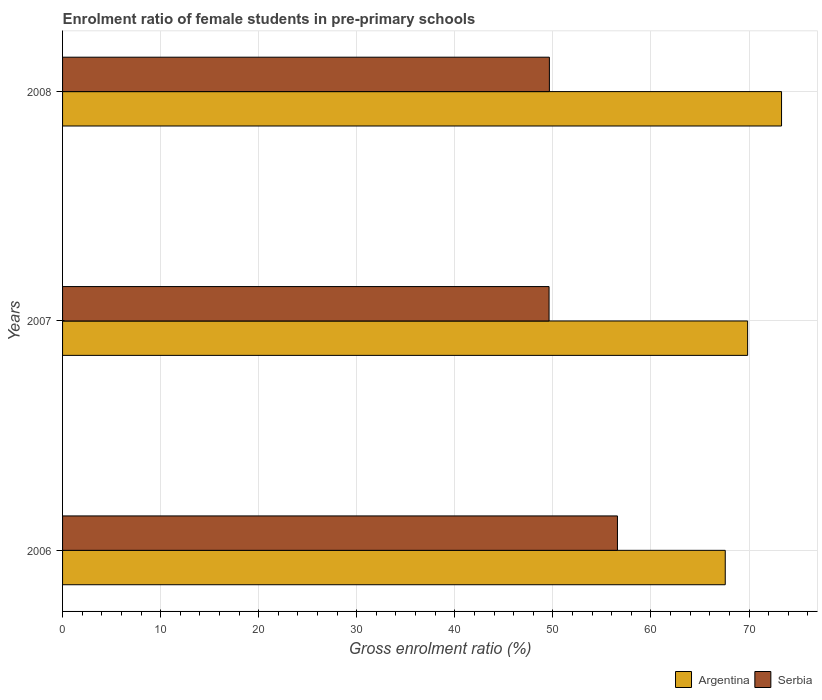How many groups of bars are there?
Your response must be concise. 3. Are the number of bars per tick equal to the number of legend labels?
Provide a short and direct response. Yes. How many bars are there on the 1st tick from the top?
Offer a terse response. 2. In how many cases, is the number of bars for a given year not equal to the number of legend labels?
Your answer should be compact. 0. What is the enrolment ratio of female students in pre-primary schools in Serbia in 2006?
Ensure brevity in your answer.  56.58. Across all years, what is the maximum enrolment ratio of female students in pre-primary schools in Serbia?
Your response must be concise. 56.58. Across all years, what is the minimum enrolment ratio of female students in pre-primary schools in Argentina?
Provide a short and direct response. 67.58. In which year was the enrolment ratio of female students in pre-primary schools in Serbia maximum?
Provide a succinct answer. 2006. What is the total enrolment ratio of female students in pre-primary schools in Argentina in the graph?
Provide a short and direct response. 210.75. What is the difference between the enrolment ratio of female students in pre-primary schools in Serbia in 2007 and that in 2008?
Give a very brief answer. -0.03. What is the difference between the enrolment ratio of female students in pre-primary schools in Argentina in 2008 and the enrolment ratio of female students in pre-primary schools in Serbia in 2007?
Offer a very short reply. 23.71. What is the average enrolment ratio of female students in pre-primary schools in Serbia per year?
Make the answer very short. 51.95. In the year 2006, what is the difference between the enrolment ratio of female students in pre-primary schools in Serbia and enrolment ratio of female students in pre-primary schools in Argentina?
Make the answer very short. -10.99. What is the ratio of the enrolment ratio of female students in pre-primary schools in Argentina in 2006 to that in 2007?
Offer a very short reply. 0.97. Is the difference between the enrolment ratio of female students in pre-primary schools in Serbia in 2006 and 2008 greater than the difference between the enrolment ratio of female students in pre-primary schools in Argentina in 2006 and 2008?
Offer a very short reply. Yes. What is the difference between the highest and the second highest enrolment ratio of female students in pre-primary schools in Argentina?
Offer a terse response. 3.46. What is the difference between the highest and the lowest enrolment ratio of female students in pre-primary schools in Serbia?
Give a very brief answer. 6.97. Is the sum of the enrolment ratio of female students in pre-primary schools in Argentina in 2006 and 2008 greater than the maximum enrolment ratio of female students in pre-primary schools in Serbia across all years?
Your answer should be compact. Yes. How many bars are there?
Provide a short and direct response. 6. Are all the bars in the graph horizontal?
Make the answer very short. Yes. What is the difference between two consecutive major ticks on the X-axis?
Your response must be concise. 10. Where does the legend appear in the graph?
Provide a succinct answer. Bottom right. How many legend labels are there?
Provide a succinct answer. 2. What is the title of the graph?
Your answer should be compact. Enrolment ratio of female students in pre-primary schools. Does "Pacific island small states" appear as one of the legend labels in the graph?
Your answer should be very brief. No. What is the label or title of the X-axis?
Keep it short and to the point. Gross enrolment ratio (%). What is the label or title of the Y-axis?
Offer a very short reply. Years. What is the Gross enrolment ratio (%) of Argentina in 2006?
Provide a succinct answer. 67.58. What is the Gross enrolment ratio (%) in Serbia in 2006?
Provide a succinct answer. 56.58. What is the Gross enrolment ratio (%) of Argentina in 2007?
Give a very brief answer. 69.86. What is the Gross enrolment ratio (%) in Serbia in 2007?
Your answer should be very brief. 49.61. What is the Gross enrolment ratio (%) of Argentina in 2008?
Your answer should be very brief. 73.32. What is the Gross enrolment ratio (%) in Serbia in 2008?
Keep it short and to the point. 49.64. Across all years, what is the maximum Gross enrolment ratio (%) of Argentina?
Give a very brief answer. 73.32. Across all years, what is the maximum Gross enrolment ratio (%) in Serbia?
Your answer should be compact. 56.58. Across all years, what is the minimum Gross enrolment ratio (%) in Argentina?
Provide a short and direct response. 67.58. Across all years, what is the minimum Gross enrolment ratio (%) in Serbia?
Keep it short and to the point. 49.61. What is the total Gross enrolment ratio (%) in Argentina in the graph?
Your answer should be compact. 210.75. What is the total Gross enrolment ratio (%) of Serbia in the graph?
Your answer should be very brief. 155.84. What is the difference between the Gross enrolment ratio (%) in Argentina in 2006 and that in 2007?
Your answer should be very brief. -2.28. What is the difference between the Gross enrolment ratio (%) of Serbia in 2006 and that in 2007?
Ensure brevity in your answer.  6.97. What is the difference between the Gross enrolment ratio (%) of Argentina in 2006 and that in 2008?
Ensure brevity in your answer.  -5.74. What is the difference between the Gross enrolment ratio (%) in Serbia in 2006 and that in 2008?
Make the answer very short. 6.94. What is the difference between the Gross enrolment ratio (%) of Argentina in 2007 and that in 2008?
Your answer should be compact. -3.46. What is the difference between the Gross enrolment ratio (%) in Serbia in 2007 and that in 2008?
Your response must be concise. -0.03. What is the difference between the Gross enrolment ratio (%) of Argentina in 2006 and the Gross enrolment ratio (%) of Serbia in 2007?
Your answer should be very brief. 17.97. What is the difference between the Gross enrolment ratio (%) in Argentina in 2006 and the Gross enrolment ratio (%) in Serbia in 2008?
Provide a succinct answer. 17.93. What is the difference between the Gross enrolment ratio (%) of Argentina in 2007 and the Gross enrolment ratio (%) of Serbia in 2008?
Your response must be concise. 20.21. What is the average Gross enrolment ratio (%) in Argentina per year?
Keep it short and to the point. 70.25. What is the average Gross enrolment ratio (%) of Serbia per year?
Offer a very short reply. 51.95. In the year 2006, what is the difference between the Gross enrolment ratio (%) in Argentina and Gross enrolment ratio (%) in Serbia?
Your answer should be compact. 10.99. In the year 2007, what is the difference between the Gross enrolment ratio (%) in Argentina and Gross enrolment ratio (%) in Serbia?
Offer a terse response. 20.25. In the year 2008, what is the difference between the Gross enrolment ratio (%) in Argentina and Gross enrolment ratio (%) in Serbia?
Ensure brevity in your answer.  23.67. What is the ratio of the Gross enrolment ratio (%) in Argentina in 2006 to that in 2007?
Your answer should be compact. 0.97. What is the ratio of the Gross enrolment ratio (%) in Serbia in 2006 to that in 2007?
Provide a short and direct response. 1.14. What is the ratio of the Gross enrolment ratio (%) of Argentina in 2006 to that in 2008?
Provide a short and direct response. 0.92. What is the ratio of the Gross enrolment ratio (%) of Serbia in 2006 to that in 2008?
Provide a succinct answer. 1.14. What is the ratio of the Gross enrolment ratio (%) in Argentina in 2007 to that in 2008?
Your answer should be compact. 0.95. What is the ratio of the Gross enrolment ratio (%) in Serbia in 2007 to that in 2008?
Your answer should be compact. 1. What is the difference between the highest and the second highest Gross enrolment ratio (%) in Argentina?
Provide a succinct answer. 3.46. What is the difference between the highest and the second highest Gross enrolment ratio (%) in Serbia?
Offer a very short reply. 6.94. What is the difference between the highest and the lowest Gross enrolment ratio (%) of Argentina?
Your response must be concise. 5.74. What is the difference between the highest and the lowest Gross enrolment ratio (%) in Serbia?
Ensure brevity in your answer.  6.97. 